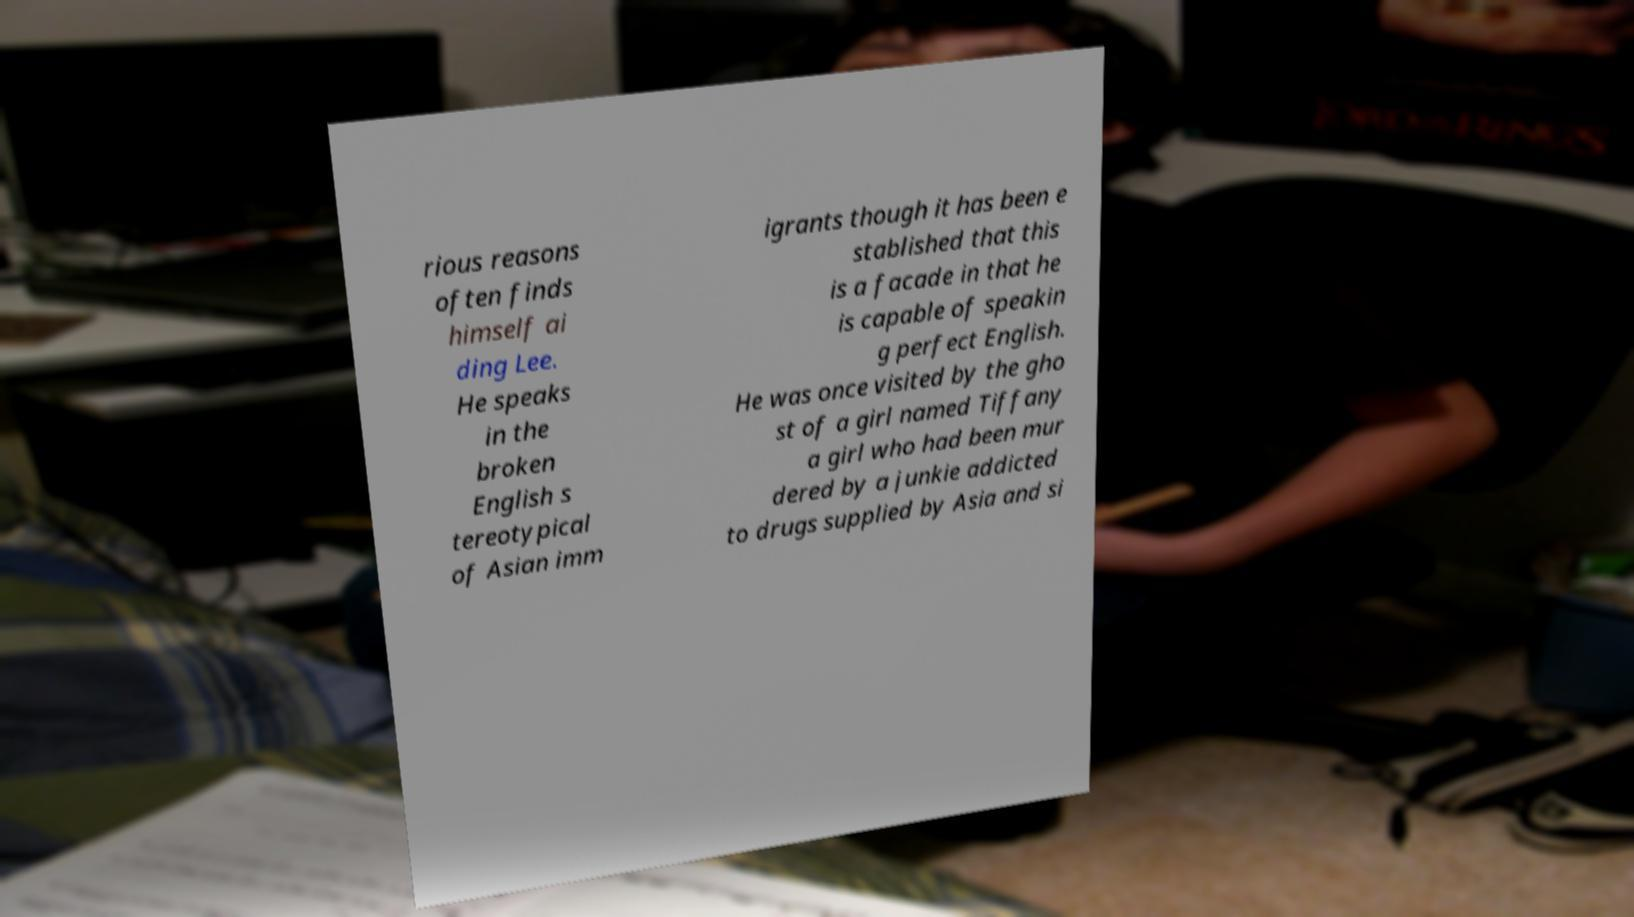Could you extract and type out the text from this image? rious reasons often finds himself ai ding Lee. He speaks in the broken English s tereotypical of Asian imm igrants though it has been e stablished that this is a facade in that he is capable of speakin g perfect English. He was once visited by the gho st of a girl named Tiffany a girl who had been mur dered by a junkie addicted to drugs supplied by Asia and si 